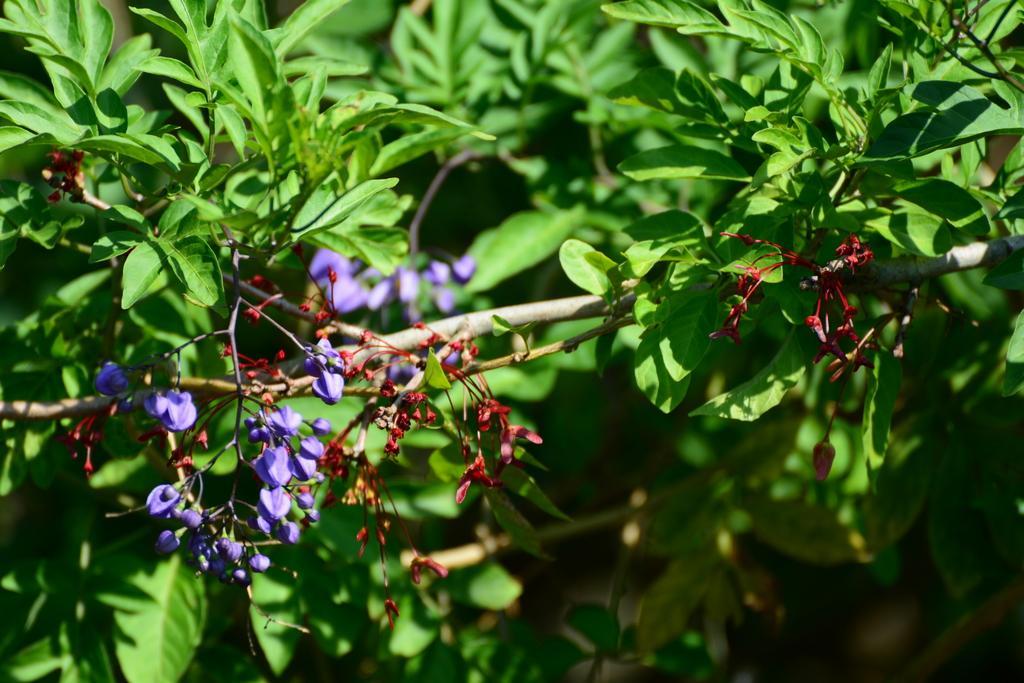Describe this image in one or two sentences. In the image in the center, we can see plants and flowers, which are in red and violet color. 